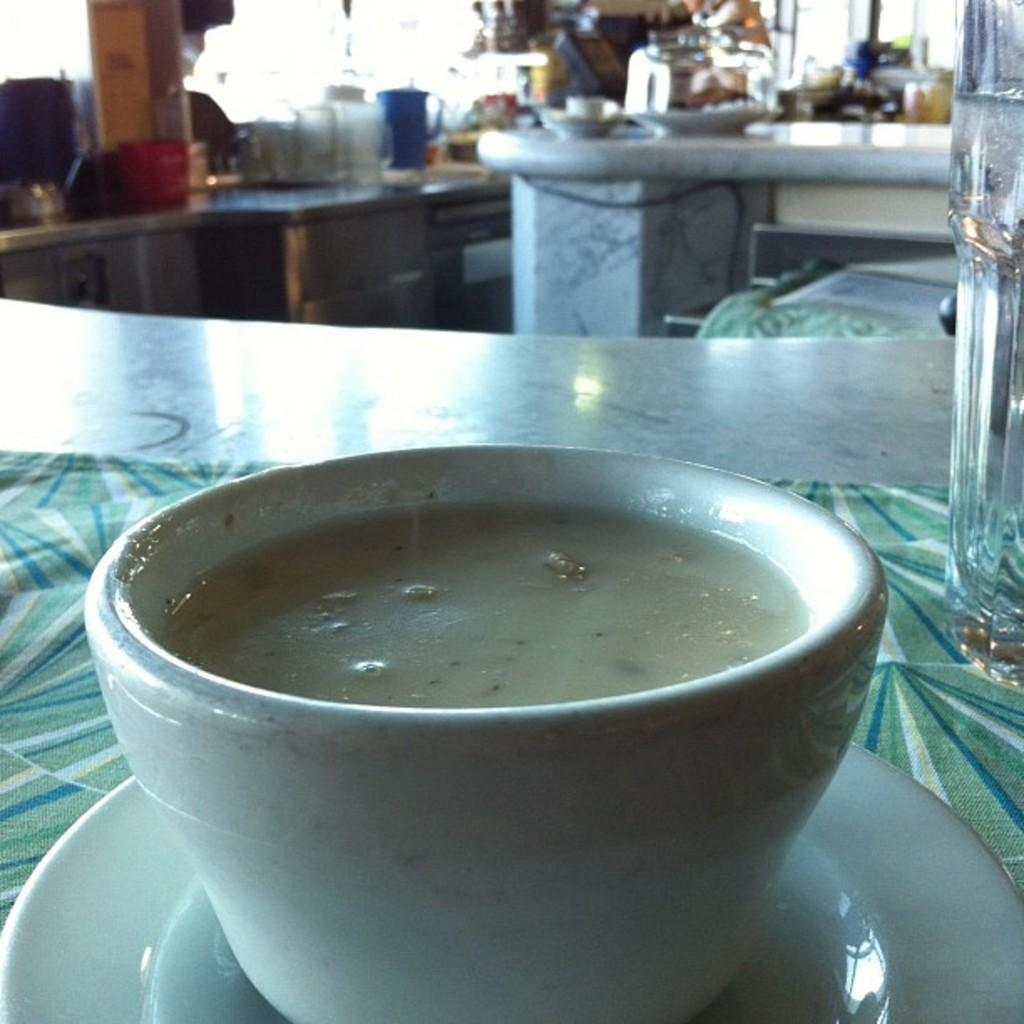What is located in the foreground of the image? There is a cup and a saucer in the foreground of the image. Can you describe the objects on the platform in the background of the image? Unfortunately, the facts provided do not give any information about the objects on the platform in the background. How many objects are placed on the platform in the background of the image? The facts provided do not give any information about the number of objects on the platform in the background. What type of tax is being discussed in the image? There is no mention of tax or any discussion in the image; it only shows a cup, a saucer, and a platform with unspecified objects in the background. 